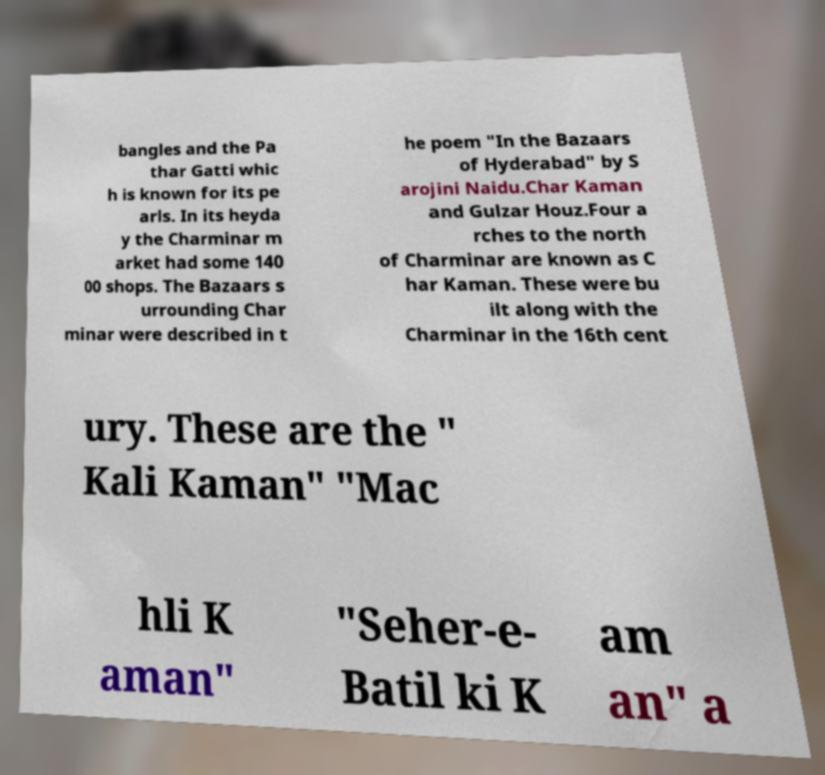There's text embedded in this image that I need extracted. Can you transcribe it verbatim? bangles and the Pa thar Gatti whic h is known for its pe arls. In its heyda y the Charminar m arket had some 140 00 shops. The Bazaars s urrounding Char minar were described in t he poem "In the Bazaars of Hyderabad" by S arojini Naidu.Char Kaman and Gulzar Houz.Four a rches to the north of Charminar are known as C har Kaman. These were bu ilt along with the Charminar in the 16th cent ury. These are the " Kali Kaman" "Mac hli K aman" "Seher-e- Batil ki K am an" a 